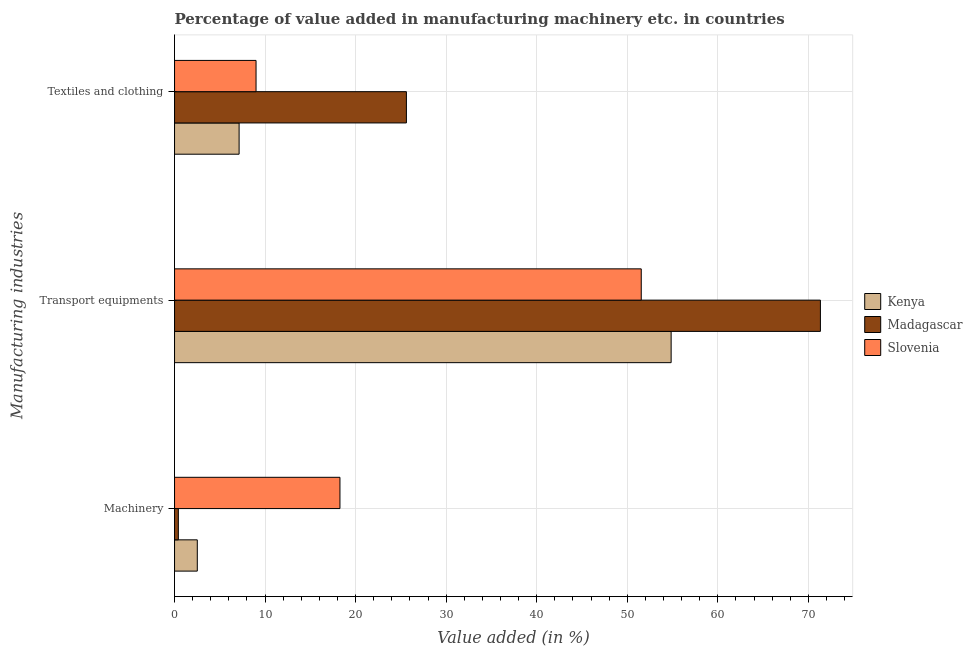How many different coloured bars are there?
Make the answer very short. 3. Are the number of bars per tick equal to the number of legend labels?
Your answer should be very brief. Yes. Are the number of bars on each tick of the Y-axis equal?
Your response must be concise. Yes. How many bars are there on the 2nd tick from the top?
Offer a terse response. 3. How many bars are there on the 1st tick from the bottom?
Offer a terse response. 3. What is the label of the 3rd group of bars from the top?
Provide a succinct answer. Machinery. What is the value added in manufacturing machinery in Kenya?
Make the answer very short. 2.51. Across all countries, what is the maximum value added in manufacturing machinery?
Your response must be concise. 18.27. Across all countries, what is the minimum value added in manufacturing textile and clothing?
Ensure brevity in your answer.  7.13. In which country was the value added in manufacturing transport equipments maximum?
Offer a terse response. Madagascar. In which country was the value added in manufacturing textile and clothing minimum?
Your response must be concise. Kenya. What is the total value added in manufacturing machinery in the graph?
Give a very brief answer. 21.2. What is the difference between the value added in manufacturing machinery in Madagascar and that in Kenya?
Keep it short and to the point. -2.09. What is the difference between the value added in manufacturing transport equipments in Madagascar and the value added in manufacturing textile and clothing in Kenya?
Keep it short and to the point. 64.2. What is the average value added in manufacturing textile and clothing per country?
Provide a succinct answer. 13.91. What is the difference between the value added in manufacturing machinery and value added in manufacturing textile and clothing in Kenya?
Offer a terse response. -4.62. In how many countries, is the value added in manufacturing transport equipments greater than 70 %?
Your answer should be very brief. 1. What is the ratio of the value added in manufacturing machinery in Madagascar to that in Slovenia?
Offer a terse response. 0.02. Is the value added in manufacturing machinery in Madagascar less than that in Slovenia?
Provide a succinct answer. Yes. Is the difference between the value added in manufacturing transport equipments in Madagascar and Slovenia greater than the difference between the value added in manufacturing textile and clothing in Madagascar and Slovenia?
Make the answer very short. Yes. What is the difference between the highest and the second highest value added in manufacturing textile and clothing?
Offer a very short reply. 16.61. What is the difference between the highest and the lowest value added in manufacturing textile and clothing?
Your answer should be very brief. 18.48. What does the 2nd bar from the top in Textiles and clothing represents?
Provide a short and direct response. Madagascar. What does the 1st bar from the bottom in Transport equipments represents?
Your answer should be very brief. Kenya. Is it the case that in every country, the sum of the value added in manufacturing machinery and value added in manufacturing transport equipments is greater than the value added in manufacturing textile and clothing?
Offer a very short reply. Yes. How many bars are there?
Ensure brevity in your answer.  9. Are the values on the major ticks of X-axis written in scientific E-notation?
Provide a short and direct response. No. Does the graph contain any zero values?
Offer a very short reply. No. Does the graph contain grids?
Make the answer very short. Yes. How many legend labels are there?
Provide a succinct answer. 3. How are the legend labels stacked?
Keep it short and to the point. Vertical. What is the title of the graph?
Keep it short and to the point. Percentage of value added in manufacturing machinery etc. in countries. Does "Seychelles" appear as one of the legend labels in the graph?
Keep it short and to the point. No. What is the label or title of the X-axis?
Keep it short and to the point. Value added (in %). What is the label or title of the Y-axis?
Ensure brevity in your answer.  Manufacturing industries. What is the Value added (in %) of Kenya in Machinery?
Your answer should be compact. 2.51. What is the Value added (in %) in Madagascar in Machinery?
Ensure brevity in your answer.  0.42. What is the Value added (in %) of Slovenia in Machinery?
Your answer should be very brief. 18.27. What is the Value added (in %) of Kenya in Transport equipments?
Make the answer very short. 54.84. What is the Value added (in %) of Madagascar in Transport equipments?
Provide a short and direct response. 71.33. What is the Value added (in %) in Slovenia in Transport equipments?
Provide a succinct answer. 51.54. What is the Value added (in %) in Kenya in Textiles and clothing?
Offer a very short reply. 7.13. What is the Value added (in %) in Madagascar in Textiles and clothing?
Provide a short and direct response. 25.61. What is the Value added (in %) in Slovenia in Textiles and clothing?
Your answer should be very brief. 9. Across all Manufacturing industries, what is the maximum Value added (in %) in Kenya?
Your answer should be very brief. 54.84. Across all Manufacturing industries, what is the maximum Value added (in %) in Madagascar?
Your response must be concise. 71.33. Across all Manufacturing industries, what is the maximum Value added (in %) of Slovenia?
Provide a short and direct response. 51.54. Across all Manufacturing industries, what is the minimum Value added (in %) of Kenya?
Provide a succinct answer. 2.51. Across all Manufacturing industries, what is the minimum Value added (in %) in Madagascar?
Your answer should be very brief. 0.42. Across all Manufacturing industries, what is the minimum Value added (in %) in Slovenia?
Provide a succinct answer. 9. What is the total Value added (in %) of Kenya in the graph?
Give a very brief answer. 64.48. What is the total Value added (in %) of Madagascar in the graph?
Offer a terse response. 97.35. What is the total Value added (in %) of Slovenia in the graph?
Provide a short and direct response. 78.81. What is the difference between the Value added (in %) in Kenya in Machinery and that in Transport equipments?
Provide a short and direct response. -52.33. What is the difference between the Value added (in %) of Madagascar in Machinery and that in Transport equipments?
Give a very brief answer. -70.91. What is the difference between the Value added (in %) in Slovenia in Machinery and that in Transport equipments?
Keep it short and to the point. -33.27. What is the difference between the Value added (in %) of Kenya in Machinery and that in Textiles and clothing?
Offer a terse response. -4.62. What is the difference between the Value added (in %) of Madagascar in Machinery and that in Textiles and clothing?
Provide a succinct answer. -25.19. What is the difference between the Value added (in %) of Slovenia in Machinery and that in Textiles and clothing?
Provide a succinct answer. 9.27. What is the difference between the Value added (in %) in Kenya in Transport equipments and that in Textiles and clothing?
Keep it short and to the point. 47.71. What is the difference between the Value added (in %) in Madagascar in Transport equipments and that in Textiles and clothing?
Provide a short and direct response. 45.72. What is the difference between the Value added (in %) of Slovenia in Transport equipments and that in Textiles and clothing?
Offer a terse response. 42.54. What is the difference between the Value added (in %) in Kenya in Machinery and the Value added (in %) in Madagascar in Transport equipments?
Your answer should be compact. -68.81. What is the difference between the Value added (in %) of Kenya in Machinery and the Value added (in %) of Slovenia in Transport equipments?
Ensure brevity in your answer.  -49.03. What is the difference between the Value added (in %) of Madagascar in Machinery and the Value added (in %) of Slovenia in Transport equipments?
Keep it short and to the point. -51.12. What is the difference between the Value added (in %) in Kenya in Machinery and the Value added (in %) in Madagascar in Textiles and clothing?
Provide a succinct answer. -23.09. What is the difference between the Value added (in %) of Kenya in Machinery and the Value added (in %) of Slovenia in Textiles and clothing?
Your answer should be very brief. -6.49. What is the difference between the Value added (in %) of Madagascar in Machinery and the Value added (in %) of Slovenia in Textiles and clothing?
Make the answer very short. -8.58. What is the difference between the Value added (in %) of Kenya in Transport equipments and the Value added (in %) of Madagascar in Textiles and clothing?
Provide a succinct answer. 29.24. What is the difference between the Value added (in %) of Kenya in Transport equipments and the Value added (in %) of Slovenia in Textiles and clothing?
Make the answer very short. 45.84. What is the difference between the Value added (in %) of Madagascar in Transport equipments and the Value added (in %) of Slovenia in Textiles and clothing?
Ensure brevity in your answer.  62.33. What is the average Value added (in %) of Kenya per Manufacturing industries?
Offer a terse response. 21.49. What is the average Value added (in %) in Madagascar per Manufacturing industries?
Ensure brevity in your answer.  32.45. What is the average Value added (in %) in Slovenia per Manufacturing industries?
Your response must be concise. 26.27. What is the difference between the Value added (in %) in Kenya and Value added (in %) in Madagascar in Machinery?
Ensure brevity in your answer.  2.09. What is the difference between the Value added (in %) of Kenya and Value added (in %) of Slovenia in Machinery?
Provide a succinct answer. -15.76. What is the difference between the Value added (in %) in Madagascar and Value added (in %) in Slovenia in Machinery?
Offer a very short reply. -17.85. What is the difference between the Value added (in %) of Kenya and Value added (in %) of Madagascar in Transport equipments?
Keep it short and to the point. -16.48. What is the difference between the Value added (in %) in Kenya and Value added (in %) in Slovenia in Transport equipments?
Provide a succinct answer. 3.3. What is the difference between the Value added (in %) of Madagascar and Value added (in %) of Slovenia in Transport equipments?
Your answer should be compact. 19.78. What is the difference between the Value added (in %) in Kenya and Value added (in %) in Madagascar in Textiles and clothing?
Provide a succinct answer. -18.48. What is the difference between the Value added (in %) in Kenya and Value added (in %) in Slovenia in Textiles and clothing?
Make the answer very short. -1.87. What is the difference between the Value added (in %) of Madagascar and Value added (in %) of Slovenia in Textiles and clothing?
Your answer should be compact. 16.61. What is the ratio of the Value added (in %) in Kenya in Machinery to that in Transport equipments?
Offer a very short reply. 0.05. What is the ratio of the Value added (in %) of Madagascar in Machinery to that in Transport equipments?
Give a very brief answer. 0.01. What is the ratio of the Value added (in %) of Slovenia in Machinery to that in Transport equipments?
Your answer should be very brief. 0.35. What is the ratio of the Value added (in %) in Kenya in Machinery to that in Textiles and clothing?
Offer a very short reply. 0.35. What is the ratio of the Value added (in %) of Madagascar in Machinery to that in Textiles and clothing?
Make the answer very short. 0.02. What is the ratio of the Value added (in %) in Slovenia in Machinery to that in Textiles and clothing?
Make the answer very short. 2.03. What is the ratio of the Value added (in %) of Kenya in Transport equipments to that in Textiles and clothing?
Offer a terse response. 7.69. What is the ratio of the Value added (in %) in Madagascar in Transport equipments to that in Textiles and clothing?
Your answer should be compact. 2.79. What is the ratio of the Value added (in %) in Slovenia in Transport equipments to that in Textiles and clothing?
Your response must be concise. 5.73. What is the difference between the highest and the second highest Value added (in %) in Kenya?
Keep it short and to the point. 47.71. What is the difference between the highest and the second highest Value added (in %) of Madagascar?
Your response must be concise. 45.72. What is the difference between the highest and the second highest Value added (in %) of Slovenia?
Ensure brevity in your answer.  33.27. What is the difference between the highest and the lowest Value added (in %) of Kenya?
Keep it short and to the point. 52.33. What is the difference between the highest and the lowest Value added (in %) of Madagascar?
Provide a succinct answer. 70.91. What is the difference between the highest and the lowest Value added (in %) of Slovenia?
Provide a short and direct response. 42.54. 